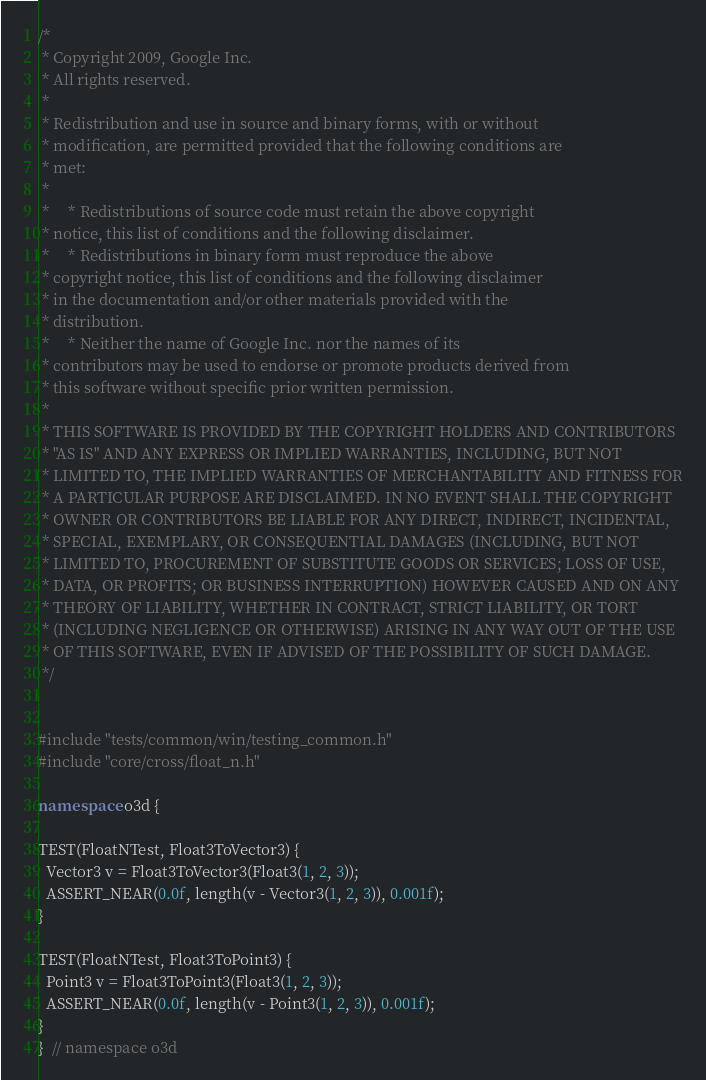Convert code to text. <code><loc_0><loc_0><loc_500><loc_500><_C++_>/*
 * Copyright 2009, Google Inc.
 * All rights reserved.
 *
 * Redistribution and use in source and binary forms, with or without
 * modification, are permitted provided that the following conditions are
 * met:
 *
 *     * Redistributions of source code must retain the above copyright
 * notice, this list of conditions and the following disclaimer.
 *     * Redistributions in binary form must reproduce the above
 * copyright notice, this list of conditions and the following disclaimer
 * in the documentation and/or other materials provided with the
 * distribution.
 *     * Neither the name of Google Inc. nor the names of its
 * contributors may be used to endorse or promote products derived from
 * this software without specific prior written permission.
 *
 * THIS SOFTWARE IS PROVIDED BY THE COPYRIGHT HOLDERS AND CONTRIBUTORS
 * "AS IS" AND ANY EXPRESS OR IMPLIED WARRANTIES, INCLUDING, BUT NOT
 * LIMITED TO, THE IMPLIED WARRANTIES OF MERCHANTABILITY AND FITNESS FOR
 * A PARTICULAR PURPOSE ARE DISCLAIMED. IN NO EVENT SHALL THE COPYRIGHT
 * OWNER OR CONTRIBUTORS BE LIABLE FOR ANY DIRECT, INDIRECT, INCIDENTAL,
 * SPECIAL, EXEMPLARY, OR CONSEQUENTIAL DAMAGES (INCLUDING, BUT NOT
 * LIMITED TO, PROCUREMENT OF SUBSTITUTE GOODS OR SERVICES; LOSS OF USE,
 * DATA, OR PROFITS; OR BUSINESS INTERRUPTION) HOWEVER CAUSED AND ON ANY
 * THEORY OF LIABILITY, WHETHER IN CONTRACT, STRICT LIABILITY, OR TORT
 * (INCLUDING NEGLIGENCE OR OTHERWISE) ARISING IN ANY WAY OUT OF THE USE
 * OF THIS SOFTWARE, EVEN IF ADVISED OF THE POSSIBILITY OF SUCH DAMAGE.
 */


#include "tests/common/win/testing_common.h"
#include "core/cross/float_n.h"

namespace o3d {

TEST(FloatNTest, Float3ToVector3) {
  Vector3 v = Float3ToVector3(Float3(1, 2, 3));
  ASSERT_NEAR(0.0f, length(v - Vector3(1, 2, 3)), 0.001f);
}

TEST(FloatNTest, Float3ToPoint3) {
  Point3 v = Float3ToPoint3(Float3(1, 2, 3));
  ASSERT_NEAR(0.0f, length(v - Point3(1, 2, 3)), 0.001f);
}
}  // namespace o3d
</code> 